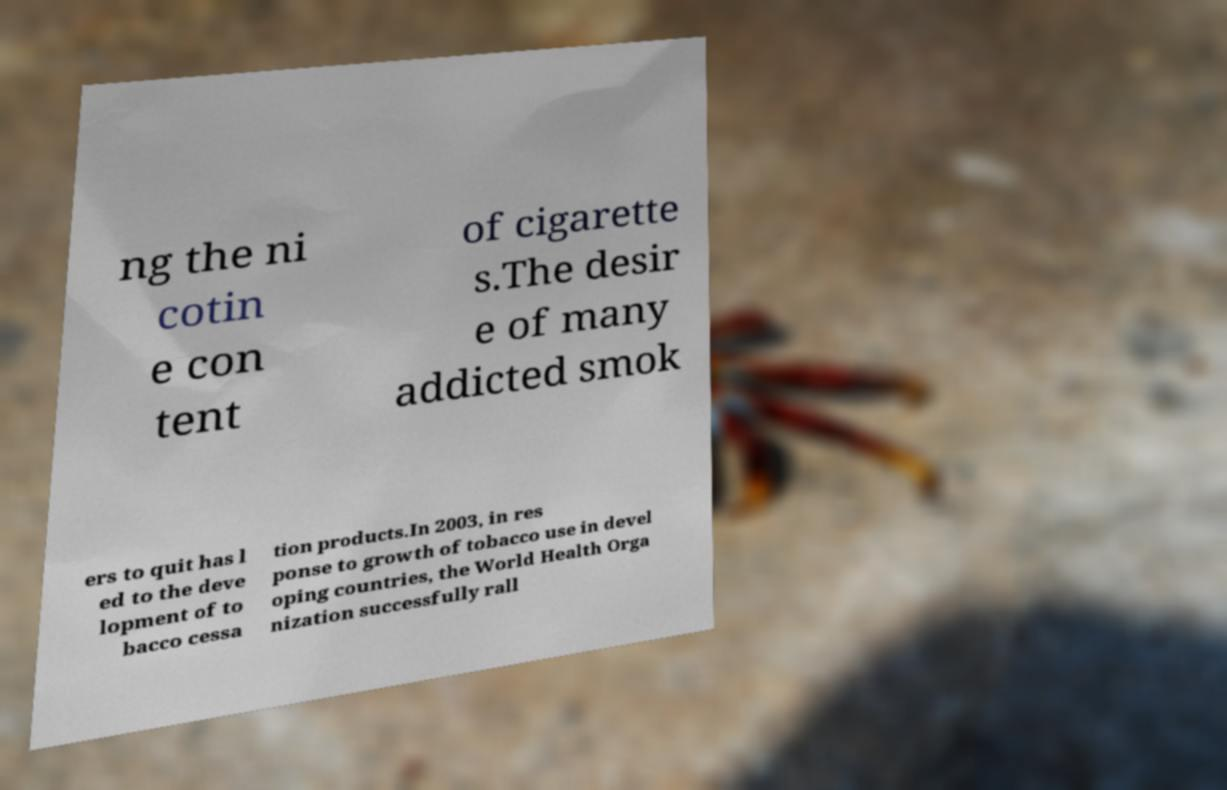Can you read and provide the text displayed in the image?This photo seems to have some interesting text. Can you extract and type it out for me? ng the ni cotin e con tent of cigarette s.The desir e of many addicted smok ers to quit has l ed to the deve lopment of to bacco cessa tion products.In 2003, in res ponse to growth of tobacco use in devel oping countries, the World Health Orga nization successfully rall 